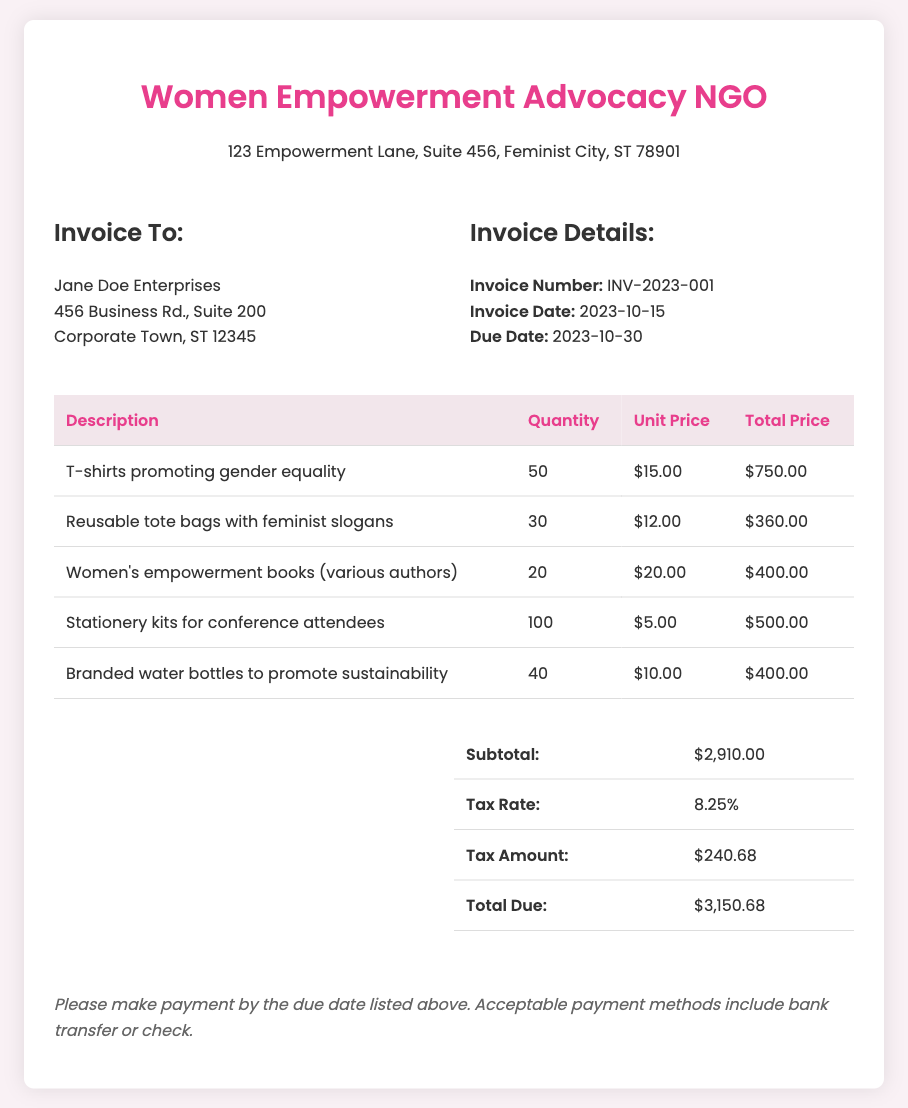What is the invoice number? The invoice number is specified in the invoice details section of the document.
Answer: INV-2023-001 What is the total due amount? The total due amount is provided in the summary section at the end of the invoice.
Answer: $3,150.68 Who is the invoice addressed to? The recipient's name is listed in the "Invoice To" section at the top of the document.
Answer: Jane Doe Enterprises What is the due date for payment? The due date for payment is mentioned in the invoice details section of the document.
Answer: 2023-10-30 How many T-shirts promoting gender equality were sold? The quantity of T-shirts sold is listed in the itemized table under quantity.
Answer: 50 What is the tax rate applied to the invoice? The tax rate is specified in the summary table of the document.
Answer: 8.25% What item had the highest total price? The highest total price can be determined by comparing the total prices for each item in the table.
Answer: T-shirts promoting gender equality What is the subtotal before tax? The subtotal before tax is provided in the summary table of the invoice.
Answer: $2,910.00 